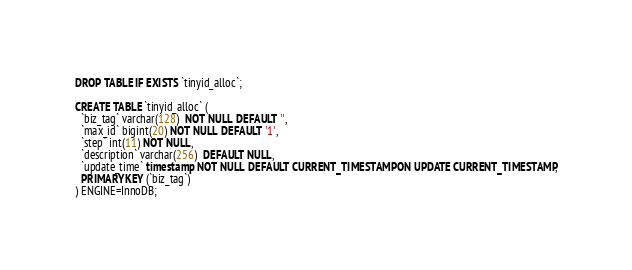<code> <loc_0><loc_0><loc_500><loc_500><_SQL_>DROP TABLE IF EXISTS `tinyid_alloc`;

CREATE TABLE `tinyid_alloc` (
  `biz_tag` varchar(128)  NOT NULL DEFAULT '',
  `max_id` bigint(20) NOT NULL DEFAULT '1',
  `step` int(11) NOT NULL,
  `description` varchar(256)  DEFAULT NULL,
  `update_time` timestamp NOT NULL DEFAULT CURRENT_TIMESTAMP ON UPDATE CURRENT_TIMESTAMP,
  PRIMARY KEY (`biz_tag`)
) ENGINE=InnoDB;
</code> 